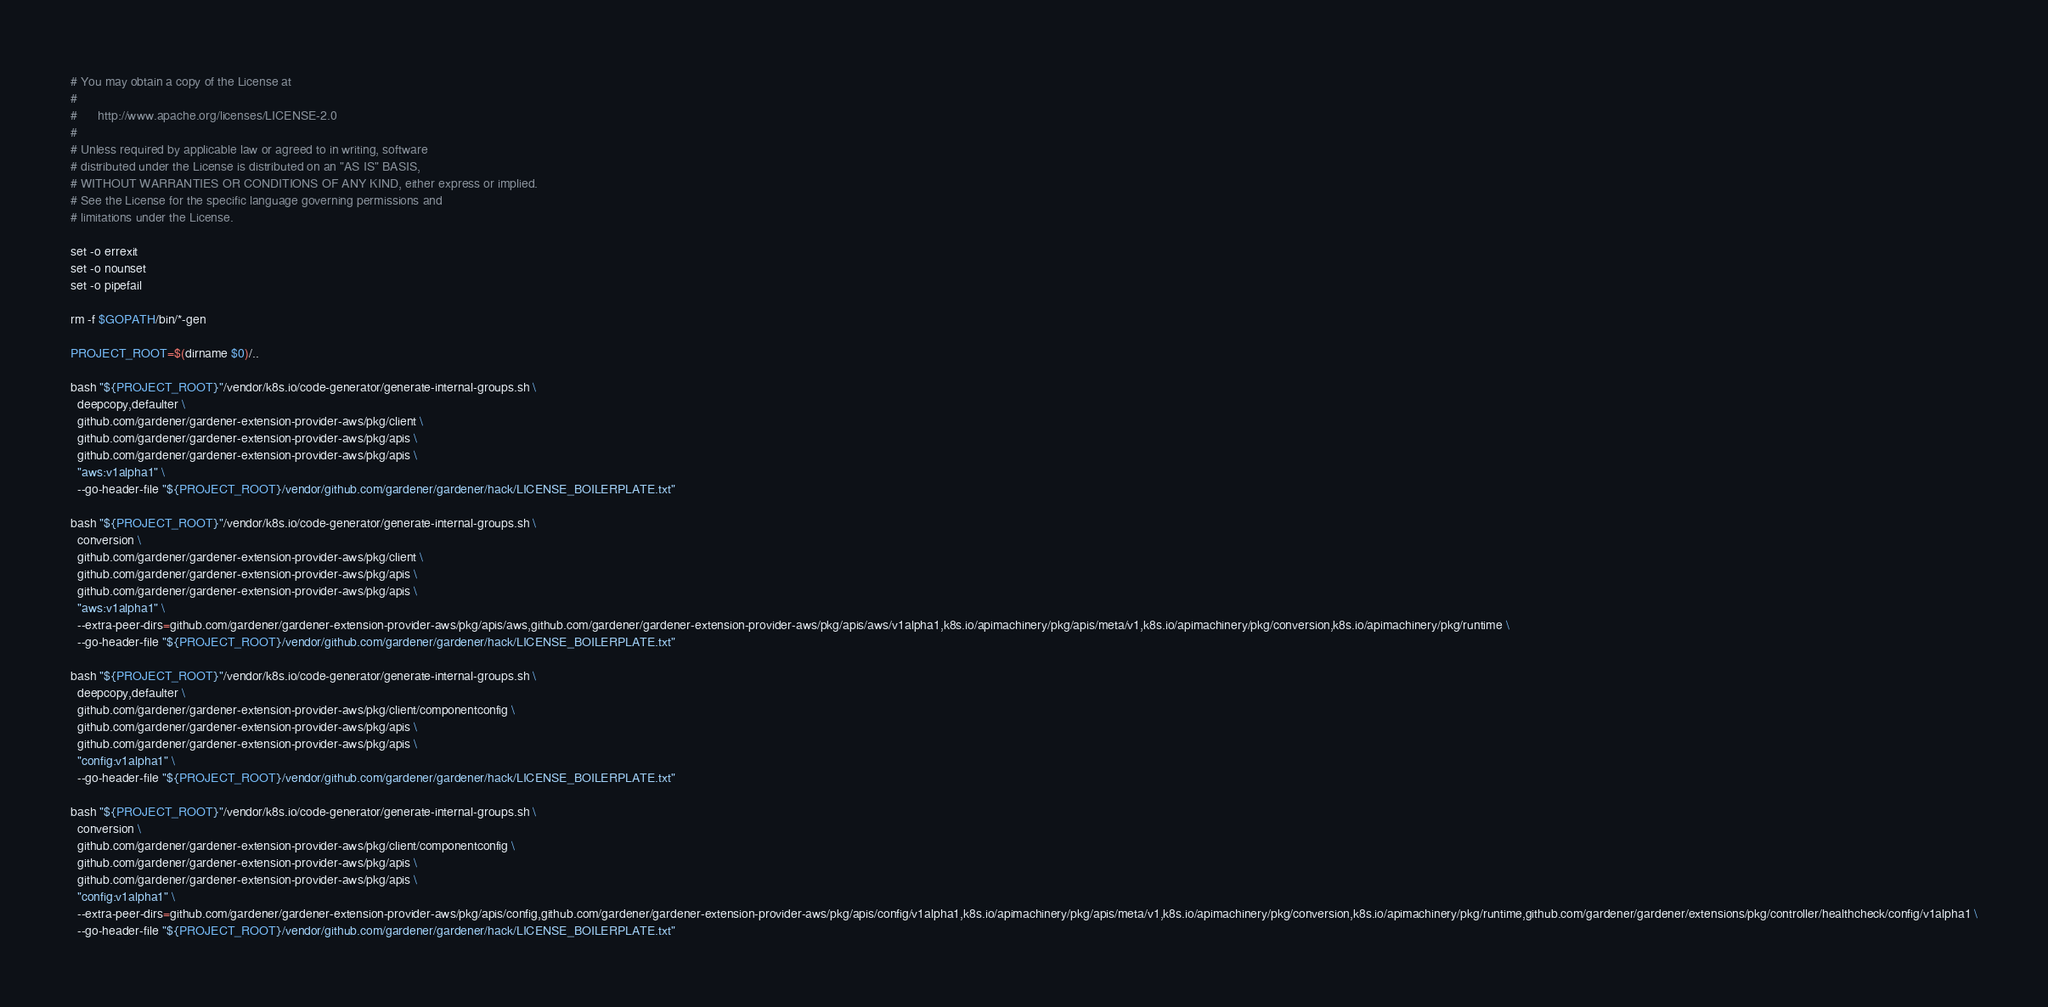Convert code to text. <code><loc_0><loc_0><loc_500><loc_500><_Bash_># You may obtain a copy of the License at
#
#      http://www.apache.org/licenses/LICENSE-2.0
#
# Unless required by applicable law or agreed to in writing, software
# distributed under the License is distributed on an "AS IS" BASIS,
# WITHOUT WARRANTIES OR CONDITIONS OF ANY KIND, either express or implied.
# See the License for the specific language governing permissions and
# limitations under the License.

set -o errexit
set -o nounset
set -o pipefail

rm -f $GOPATH/bin/*-gen

PROJECT_ROOT=$(dirname $0)/..

bash "${PROJECT_ROOT}"/vendor/k8s.io/code-generator/generate-internal-groups.sh \
  deepcopy,defaulter \
  github.com/gardener/gardener-extension-provider-aws/pkg/client \
  github.com/gardener/gardener-extension-provider-aws/pkg/apis \
  github.com/gardener/gardener-extension-provider-aws/pkg/apis \
  "aws:v1alpha1" \
  --go-header-file "${PROJECT_ROOT}/vendor/github.com/gardener/gardener/hack/LICENSE_BOILERPLATE.txt"

bash "${PROJECT_ROOT}"/vendor/k8s.io/code-generator/generate-internal-groups.sh \
  conversion \
  github.com/gardener/gardener-extension-provider-aws/pkg/client \
  github.com/gardener/gardener-extension-provider-aws/pkg/apis \
  github.com/gardener/gardener-extension-provider-aws/pkg/apis \
  "aws:v1alpha1" \
  --extra-peer-dirs=github.com/gardener/gardener-extension-provider-aws/pkg/apis/aws,github.com/gardener/gardener-extension-provider-aws/pkg/apis/aws/v1alpha1,k8s.io/apimachinery/pkg/apis/meta/v1,k8s.io/apimachinery/pkg/conversion,k8s.io/apimachinery/pkg/runtime \
  --go-header-file "${PROJECT_ROOT}/vendor/github.com/gardener/gardener/hack/LICENSE_BOILERPLATE.txt"

bash "${PROJECT_ROOT}"/vendor/k8s.io/code-generator/generate-internal-groups.sh \
  deepcopy,defaulter \
  github.com/gardener/gardener-extension-provider-aws/pkg/client/componentconfig \
  github.com/gardener/gardener-extension-provider-aws/pkg/apis \
  github.com/gardener/gardener-extension-provider-aws/pkg/apis \
  "config:v1alpha1" \
  --go-header-file "${PROJECT_ROOT}/vendor/github.com/gardener/gardener/hack/LICENSE_BOILERPLATE.txt"

bash "${PROJECT_ROOT}"/vendor/k8s.io/code-generator/generate-internal-groups.sh \
  conversion \
  github.com/gardener/gardener-extension-provider-aws/pkg/client/componentconfig \
  github.com/gardener/gardener-extension-provider-aws/pkg/apis \
  github.com/gardener/gardener-extension-provider-aws/pkg/apis \
  "config:v1alpha1" \
  --extra-peer-dirs=github.com/gardener/gardener-extension-provider-aws/pkg/apis/config,github.com/gardener/gardener-extension-provider-aws/pkg/apis/config/v1alpha1,k8s.io/apimachinery/pkg/apis/meta/v1,k8s.io/apimachinery/pkg/conversion,k8s.io/apimachinery/pkg/runtime,github.com/gardener/gardener/extensions/pkg/controller/healthcheck/config/v1alpha1 \
  --go-header-file "${PROJECT_ROOT}/vendor/github.com/gardener/gardener/hack/LICENSE_BOILERPLATE.txt"
</code> 